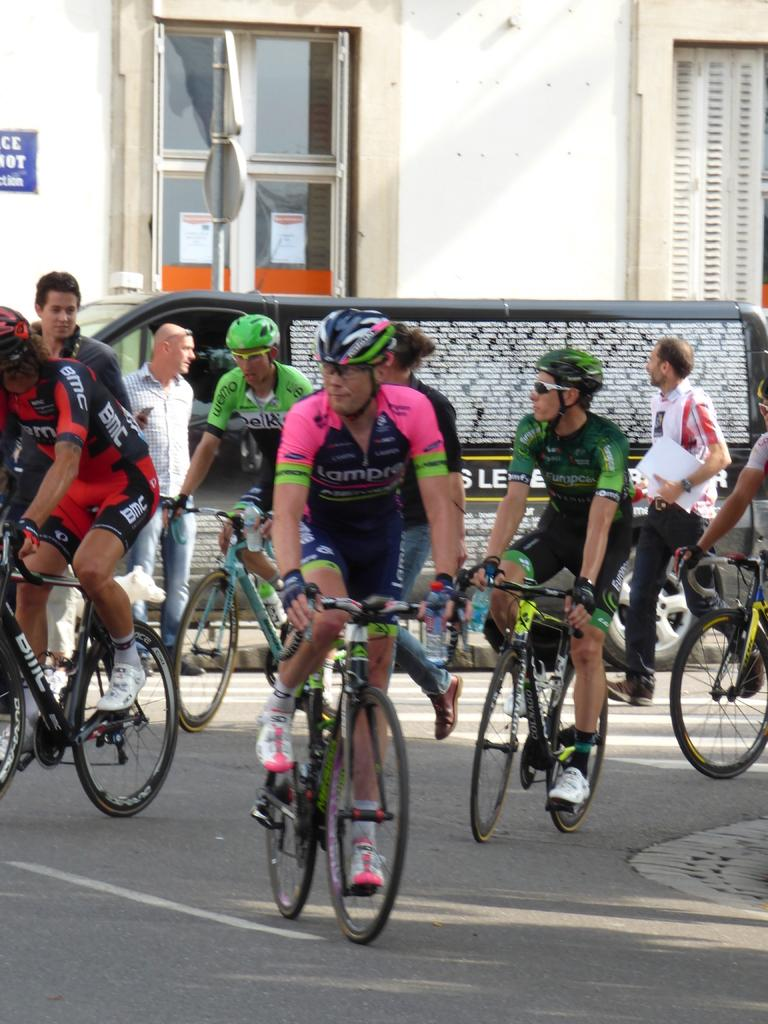What are the persons in the image doing? The persons in the image are riding bicycles. How many persons can be seen riding bicycles in the image? There are two visible persons on the road. What is behind the persons riding bicycles? There is a vehicle behind the persons on the road. What structures can be seen in the image? There is a pole, a building wall, and a window visible in the image. Can you see any monkeys eating bananas in the image? There are no monkeys or bananas present in the image. What type of ear is visible on the persons riding bicycles in the image? The persons riding bicycles do not have any visible ears in the image. 